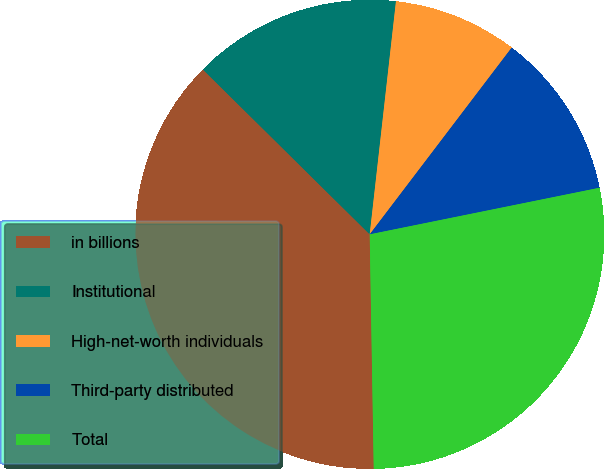Convert chart to OTSL. <chart><loc_0><loc_0><loc_500><loc_500><pie_chart><fcel>in billions<fcel>Institutional<fcel>High-net-worth individuals<fcel>Third-party distributed<fcel>Total<nl><fcel>37.68%<fcel>14.38%<fcel>8.56%<fcel>11.47%<fcel>27.91%<nl></chart> 